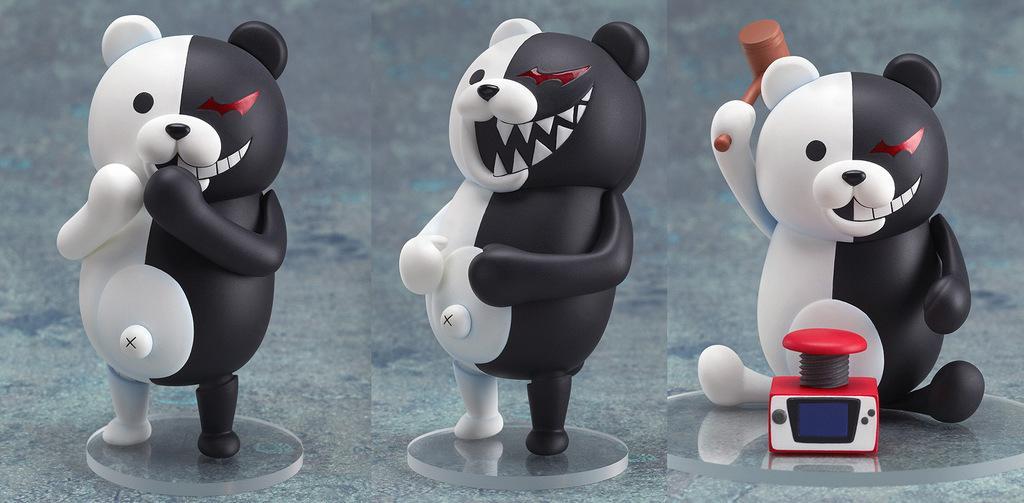Describe this image in one or two sentences. In the picture we can see three images of panda dolls, in the first image we can see panda is standing and keeping the hands on the mouth and in the second image we can see the panda is standing and keeping its hands on the stomach and in the third image we can see the panda is sitting and holding the hammer and trying to hit on the button which is red in color. 